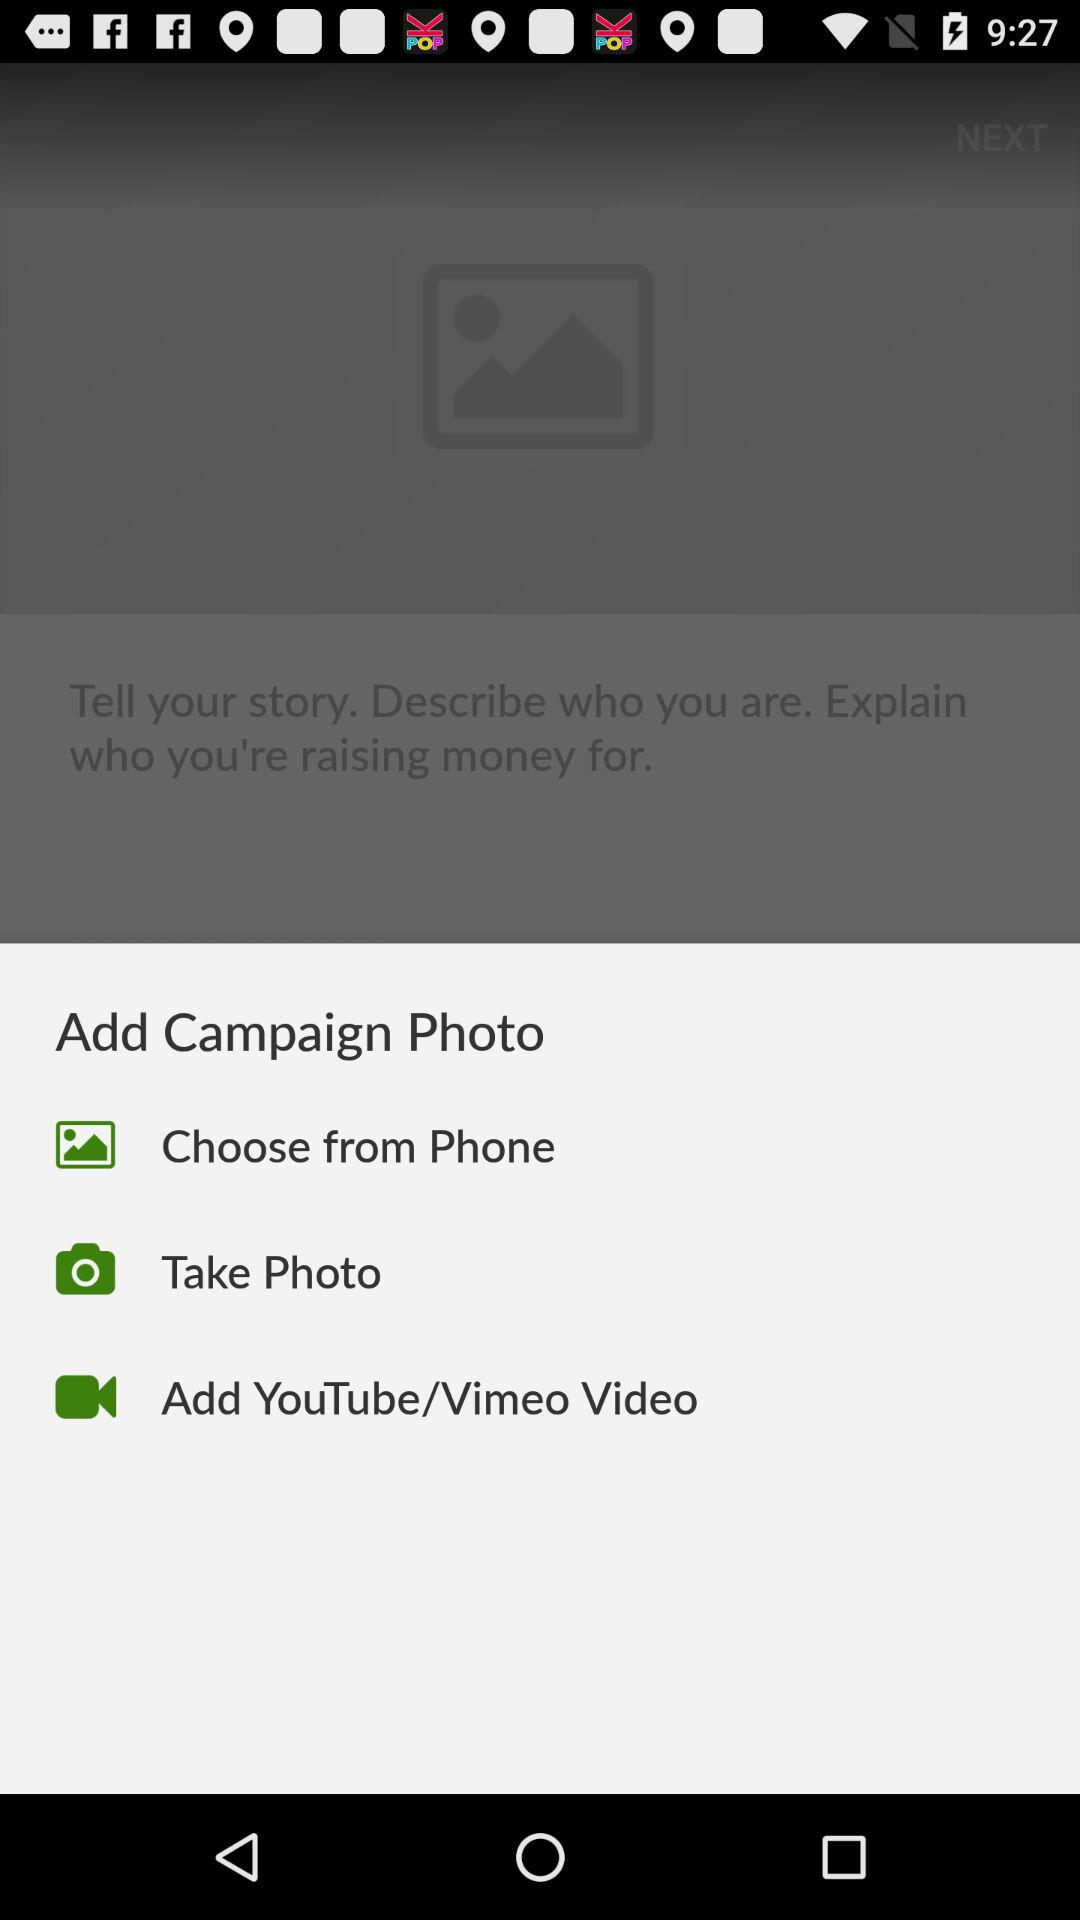What are the different options to add a photo? The different options are to add a photo are "Choose from Phone", "Take Photo" and "Add YouTube/Vimeo Video". 